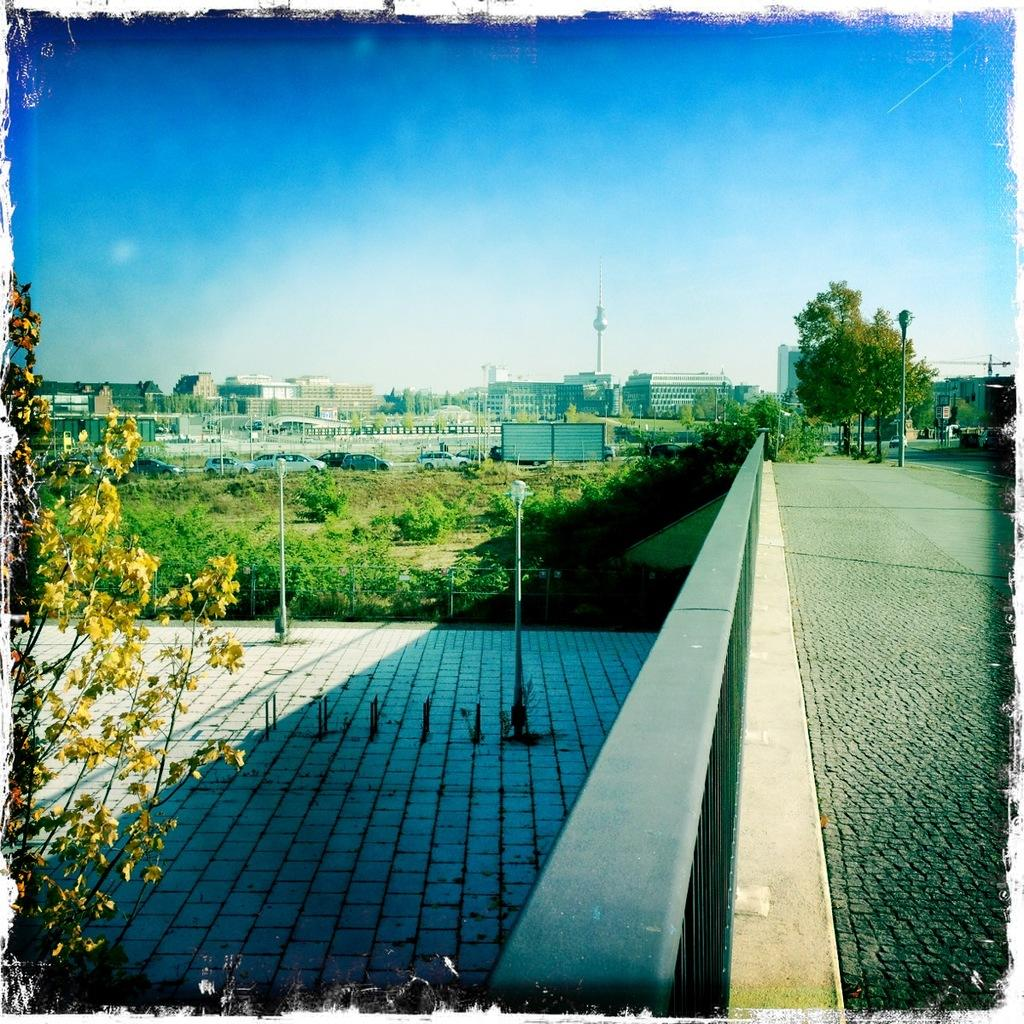What type of living organisms can be seen in the image? Plants are visible in the image. What type of structures are present in the image? Light poles and buildings are present in the image. What is the surface on which the plants and light poles are situated? The floor is visible in the image. What type of pathway is depicted in the image? There is a road in the image. What can be seen in the background of the image? Buildings and the sky are visible in the background of the image. Can you see any fangs on the plants in the image? There are no fangs present on the plants in the image, as plants do not have fangs. How many zebras can be seen grazing on the grass in the image? There are no zebras present in the image; it features plants, light poles, a road, buildings, and the sky. 